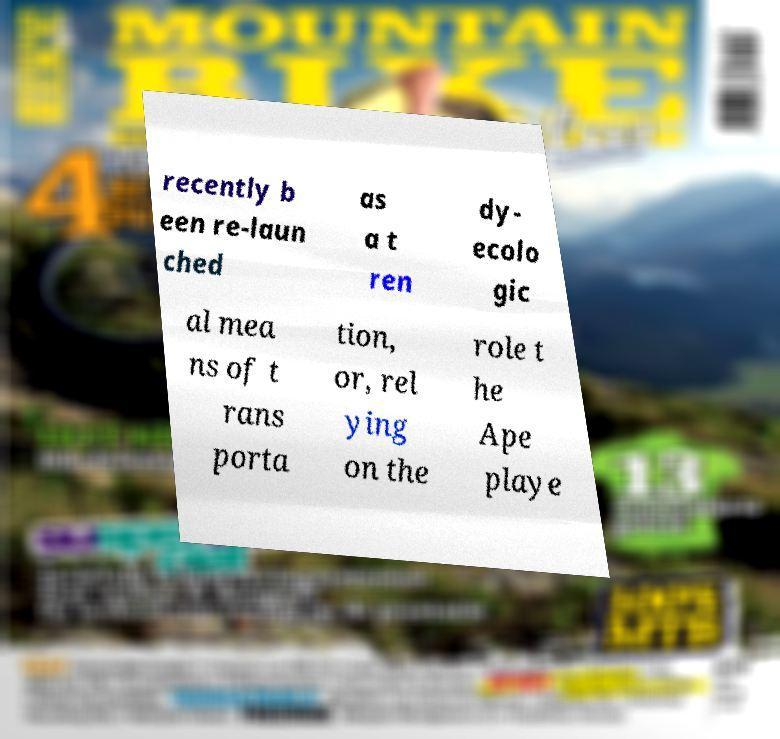For documentation purposes, I need the text within this image transcribed. Could you provide that? recently b een re-laun ched as a t ren dy- ecolo gic al mea ns of t rans porta tion, or, rel ying on the role t he Ape playe 